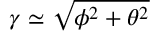<formula> <loc_0><loc_0><loc_500><loc_500>\gamma \simeq \sqrt { \phi ^ { 2 } + \theta ^ { 2 } }</formula> 